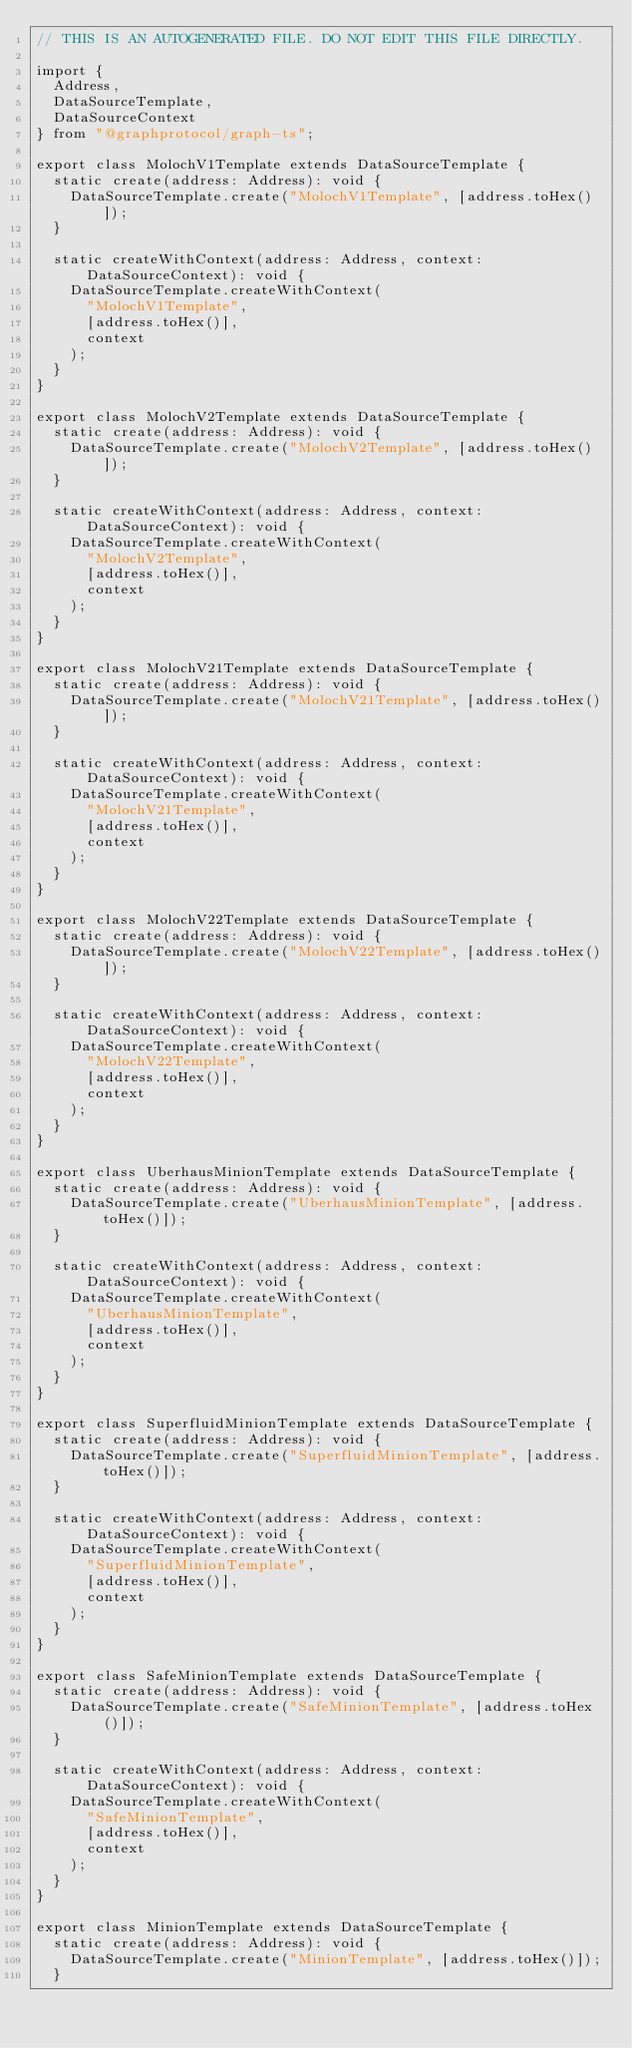Convert code to text. <code><loc_0><loc_0><loc_500><loc_500><_TypeScript_>// THIS IS AN AUTOGENERATED FILE. DO NOT EDIT THIS FILE DIRECTLY.

import {
  Address,
  DataSourceTemplate,
  DataSourceContext
} from "@graphprotocol/graph-ts";

export class MolochV1Template extends DataSourceTemplate {
  static create(address: Address): void {
    DataSourceTemplate.create("MolochV1Template", [address.toHex()]);
  }

  static createWithContext(address: Address, context: DataSourceContext): void {
    DataSourceTemplate.createWithContext(
      "MolochV1Template",
      [address.toHex()],
      context
    );
  }
}

export class MolochV2Template extends DataSourceTemplate {
  static create(address: Address): void {
    DataSourceTemplate.create("MolochV2Template", [address.toHex()]);
  }

  static createWithContext(address: Address, context: DataSourceContext): void {
    DataSourceTemplate.createWithContext(
      "MolochV2Template",
      [address.toHex()],
      context
    );
  }
}

export class MolochV21Template extends DataSourceTemplate {
  static create(address: Address): void {
    DataSourceTemplate.create("MolochV21Template", [address.toHex()]);
  }

  static createWithContext(address: Address, context: DataSourceContext): void {
    DataSourceTemplate.createWithContext(
      "MolochV21Template",
      [address.toHex()],
      context
    );
  }
}

export class MolochV22Template extends DataSourceTemplate {
  static create(address: Address): void {
    DataSourceTemplate.create("MolochV22Template", [address.toHex()]);
  }

  static createWithContext(address: Address, context: DataSourceContext): void {
    DataSourceTemplate.createWithContext(
      "MolochV22Template",
      [address.toHex()],
      context
    );
  }
}

export class UberhausMinionTemplate extends DataSourceTemplate {
  static create(address: Address): void {
    DataSourceTemplate.create("UberhausMinionTemplate", [address.toHex()]);
  }

  static createWithContext(address: Address, context: DataSourceContext): void {
    DataSourceTemplate.createWithContext(
      "UberhausMinionTemplate",
      [address.toHex()],
      context
    );
  }
}

export class SuperfluidMinionTemplate extends DataSourceTemplate {
  static create(address: Address): void {
    DataSourceTemplate.create("SuperfluidMinionTemplate", [address.toHex()]);
  }

  static createWithContext(address: Address, context: DataSourceContext): void {
    DataSourceTemplate.createWithContext(
      "SuperfluidMinionTemplate",
      [address.toHex()],
      context
    );
  }
}

export class SafeMinionTemplate extends DataSourceTemplate {
  static create(address: Address): void {
    DataSourceTemplate.create("SafeMinionTemplate", [address.toHex()]);
  }

  static createWithContext(address: Address, context: DataSourceContext): void {
    DataSourceTemplate.createWithContext(
      "SafeMinionTemplate",
      [address.toHex()],
      context
    );
  }
}

export class MinionTemplate extends DataSourceTemplate {
  static create(address: Address): void {
    DataSourceTemplate.create("MinionTemplate", [address.toHex()]);
  }
</code> 